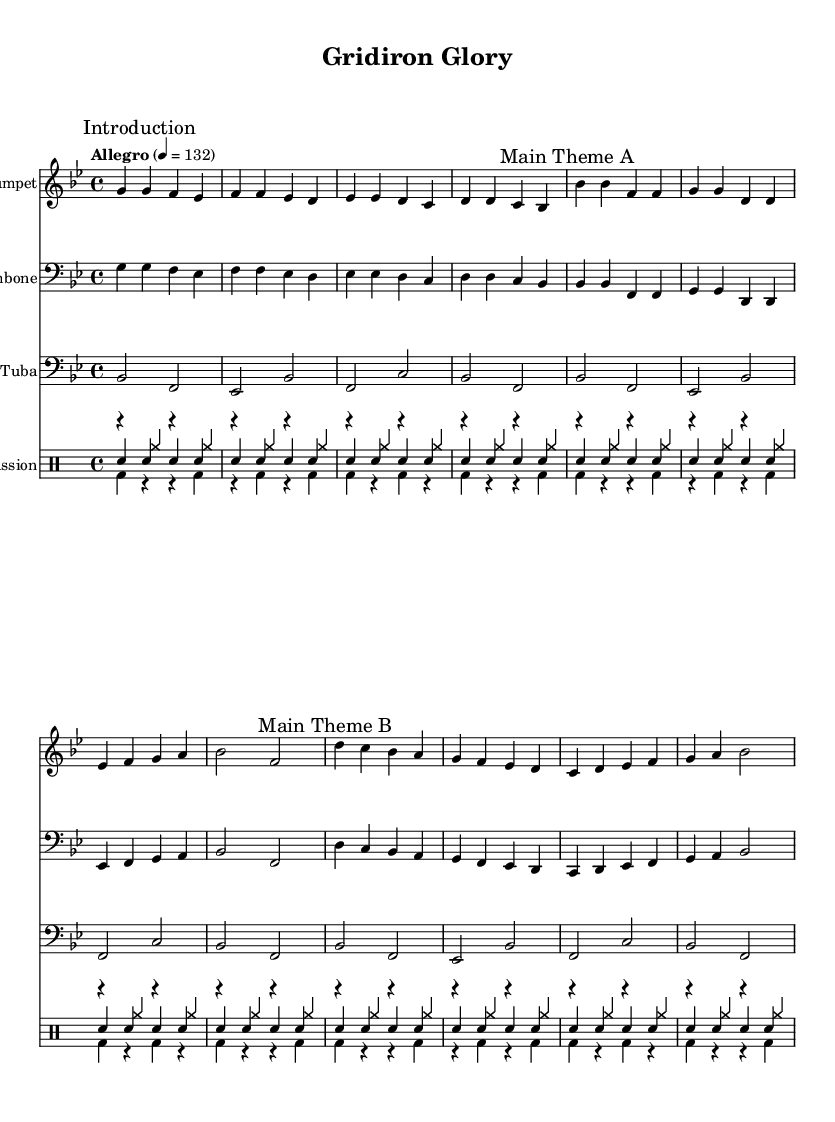What is the key signature of this music? The key signature is indicated at the beginning of the score. The presence of two flats (B-flat and E-flat) tells us that the key is B-flat major.
Answer: B-flat major What is the time signature of this music? The time signature is shown at the beginning of the score as 4/4, which means there are four beats in each measure and the quarter note gets one beat.
Answer: 4/4 What is the tempo marking for this piece? The tempo marking "Allegro" is stated at the beginning with a metronome marking of quarter note equals 132, indicating a fast pace.
Answer: Allegro How many main themes are there in this arrangement? The music includes two sections labeled "Main Theme A" and "Main Theme B," indicating that there are two distinct main themes.
Answer: Two What instruments are included in this arrangement? The score lists the instruments at the beginning. The instruments are Trumpet, Trombone, Tuba, Snare, Bass Drum, and Cymbals.
Answer: Trumpet, Trombone, Tuba, Snare, Bass Drum, Cymbals What type of music arrangement is this? The arrangement is structured for a marching band, characterized by its upbeat tempo and instrumentation typical in halftime shows.
Answer: Marching band What rhythmic elements are prominent in the percussion section? The percussion includes consistent repeated rhythms with four snare hits, followed by alternating patterns in the bass drum and cymbals, contributing to a driving feel.
Answer: Repeated rhythms 